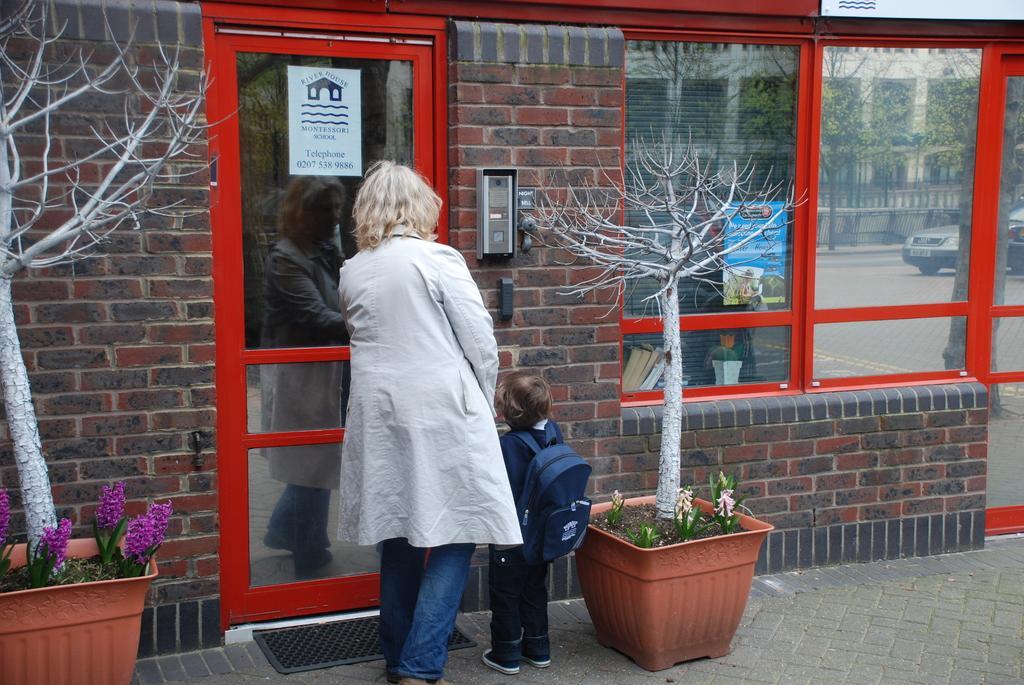Could you give a brief overview of what you see in this image? As we can see in the image there is a woman and a kid who is standing in front of a building. The women is wearing white jacket and the kid is wearing a navy blue colour bag. On either side of them there are plants kept in a pot. On the ground there is a doormat. The women and the kid are standing in front of the building which is of red bricks and on the window of the building we can see the reflection of a building and the trees and on the road the car. 